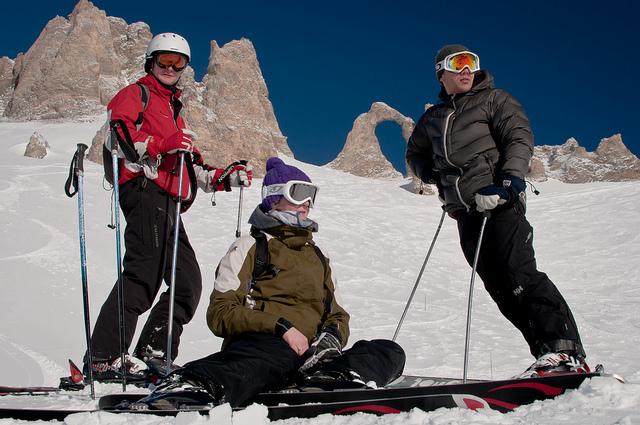What color is the skier's jacket on the left?
Give a very brief answer. Red. What are the boys doing?
Write a very short answer. Skiing. Is it snowing in the photo?
Give a very brief answer. No. 